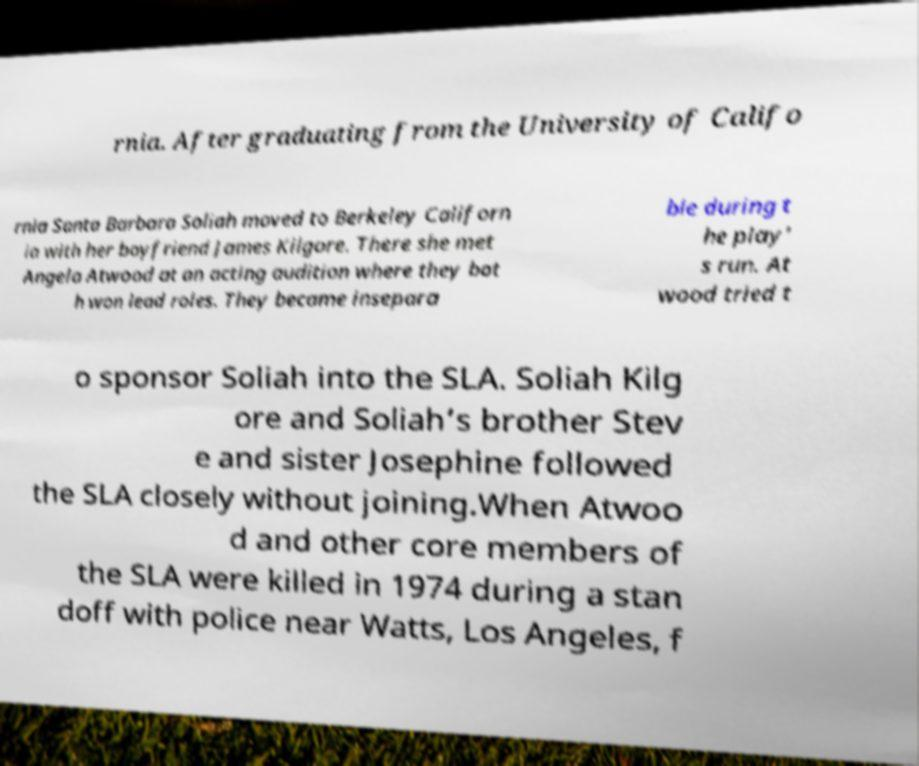For documentation purposes, I need the text within this image transcribed. Could you provide that? rnia. After graduating from the University of Califo rnia Santa Barbara Soliah moved to Berkeley Californ ia with her boyfriend James Kilgore. There she met Angela Atwood at an acting audition where they bot h won lead roles. They became insepara ble during t he play' s run. At wood tried t o sponsor Soliah into the SLA. Soliah Kilg ore and Soliah’s brother Stev e and sister Josephine followed the SLA closely without joining.When Atwoo d and other core members of the SLA were killed in 1974 during a stan doff with police near Watts, Los Angeles, f 